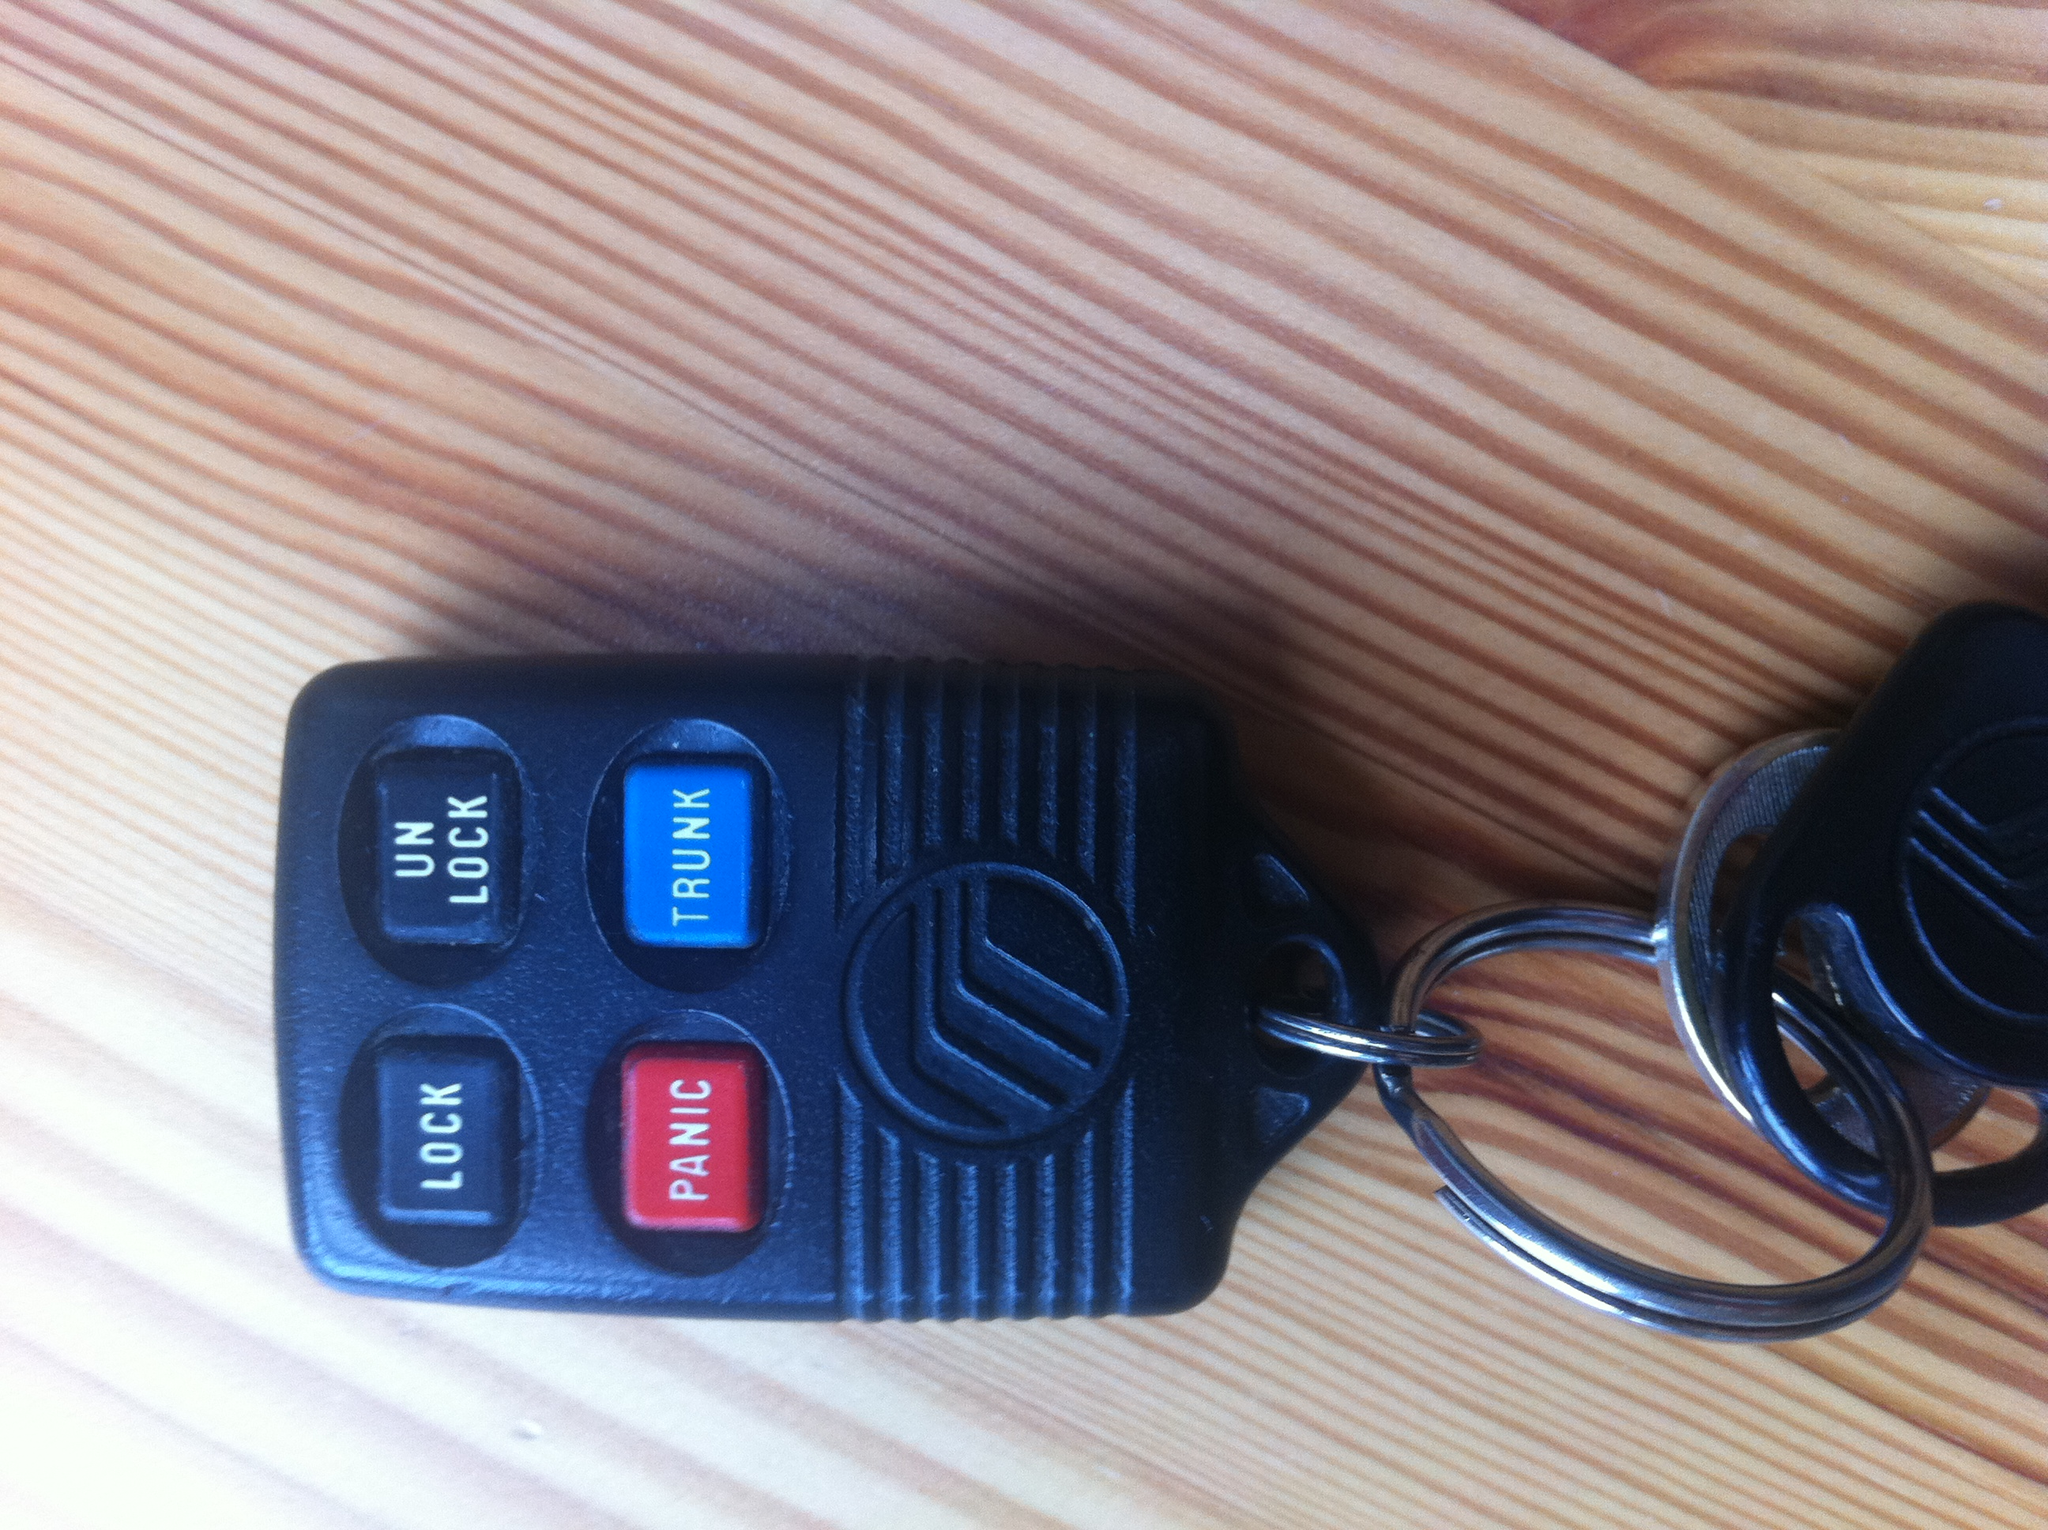How does each button on the key function? The buttons on the key fob function as follows:
1. The 'LOCK' button secures the vehicle by locking all doors.
2. The 'UNLOCK' button releases the locks, allowing entry to the vehicle.
3. The 'TRUNK' button opens the trunk space for easy access.
4. The 'PANIC' button activates the vehicle's alarm system to draw attention in case of an emergency. 